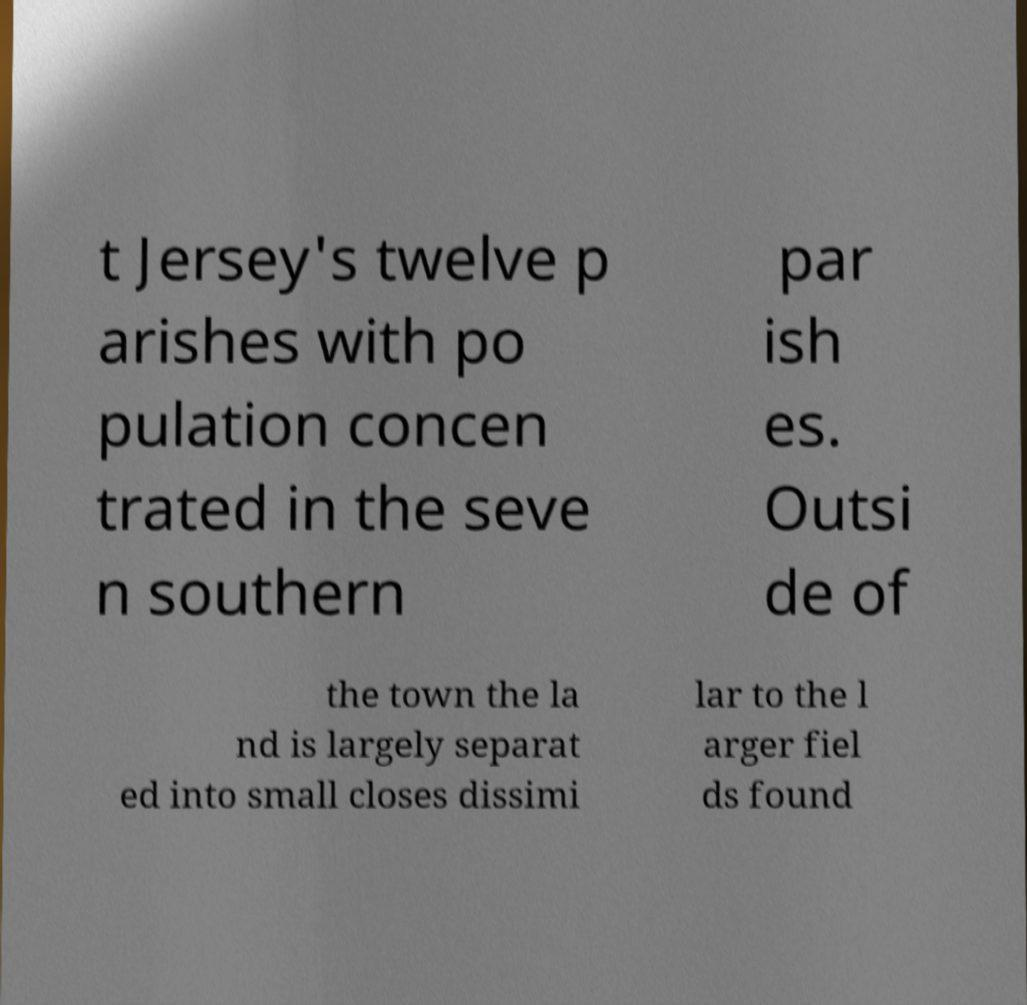Can you accurately transcribe the text from the provided image for me? t Jersey's twelve p arishes with po pulation concen trated in the seve n southern par ish es. Outsi de of the town the la nd is largely separat ed into small closes dissimi lar to the l arger fiel ds found 